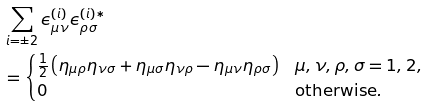Convert formula to latex. <formula><loc_0><loc_0><loc_500><loc_500>& \sum _ { i = \pm 2 } \epsilon _ { \mu \nu } ^ { ( i ) } \epsilon _ { \rho \sigma } ^ { ( i ) \ast } \\ & = \begin{cases} \frac { 1 } { 2 } \left ( \eta _ { \mu \rho } \eta _ { \nu \sigma } + \eta _ { \mu \sigma } \eta _ { \nu \rho } - \eta _ { \mu \nu } \eta _ { \rho \sigma } \right ) & \mu , \nu , \rho , \sigma = 1 , 2 , \\ 0 & \text {otherwise} . \end{cases}</formula> 